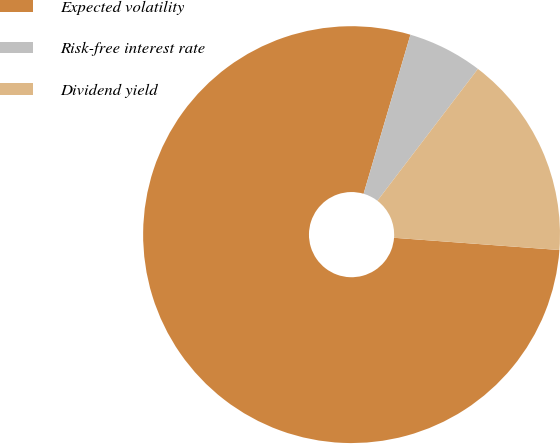Convert chart. <chart><loc_0><loc_0><loc_500><loc_500><pie_chart><fcel>Expected volatility<fcel>Risk-free interest rate<fcel>Dividend yield<nl><fcel>78.39%<fcel>5.81%<fcel>15.81%<nl></chart> 